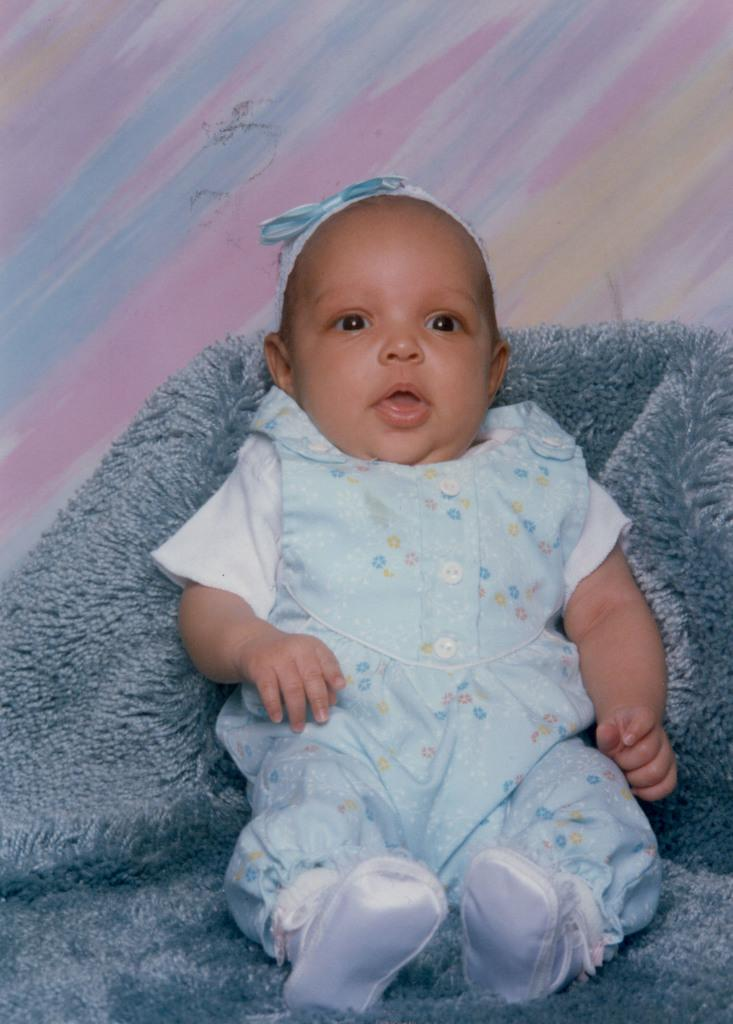What is the main subject of the image? There is a baby in the image. Where is the baby located? The baby is sitting on a couch. What can be seen in the background of the image? There is a wall in the background of the image. What type of needle is the baby holding in the image? There is no needle present in the image. What songs is the baby singing in the image? There is no indication that the baby is singing in the image. 